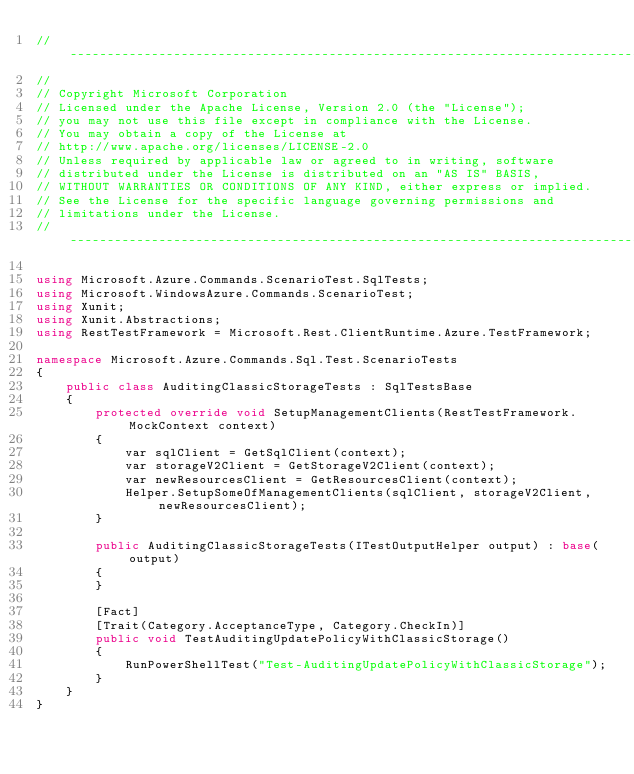Convert code to text. <code><loc_0><loc_0><loc_500><loc_500><_C#_>// ----------------------------------------------------------------------------------
//
// Copyright Microsoft Corporation
// Licensed under the Apache License, Version 2.0 (the "License");
// you may not use this file except in compliance with the License.
// You may obtain a copy of the License at
// http://www.apache.org/licenses/LICENSE-2.0
// Unless required by applicable law or agreed to in writing, software
// distributed under the License is distributed on an "AS IS" BASIS,
// WITHOUT WARRANTIES OR CONDITIONS OF ANY KIND, either express or implied.
// See the License for the specific language governing permissions and
// limitations under the License.
// ----------------------------------------------------------------------------------

using Microsoft.Azure.Commands.ScenarioTest.SqlTests;
using Microsoft.WindowsAzure.Commands.ScenarioTest;
using Xunit;
using Xunit.Abstractions;
using RestTestFramework = Microsoft.Rest.ClientRuntime.Azure.TestFramework;

namespace Microsoft.Azure.Commands.Sql.Test.ScenarioTests
{
    public class AuditingClassicStorageTests : SqlTestsBase
    {
        protected override void SetupManagementClients(RestTestFramework.MockContext context)
        {
            var sqlClient = GetSqlClient(context);
            var storageV2Client = GetStorageV2Client(context);
            var newResourcesClient = GetResourcesClient(context);
            Helper.SetupSomeOfManagementClients(sqlClient, storageV2Client, newResourcesClient);
        }

        public AuditingClassicStorageTests(ITestOutputHelper output) : base(output)
        {
        }
     
        [Fact]
        [Trait(Category.AcceptanceType, Category.CheckIn)]
        public void TestAuditingUpdatePolicyWithClassicStorage()
        {
            RunPowerShellTest("Test-AuditingUpdatePolicyWithClassicStorage");
        }
    }
}
</code> 